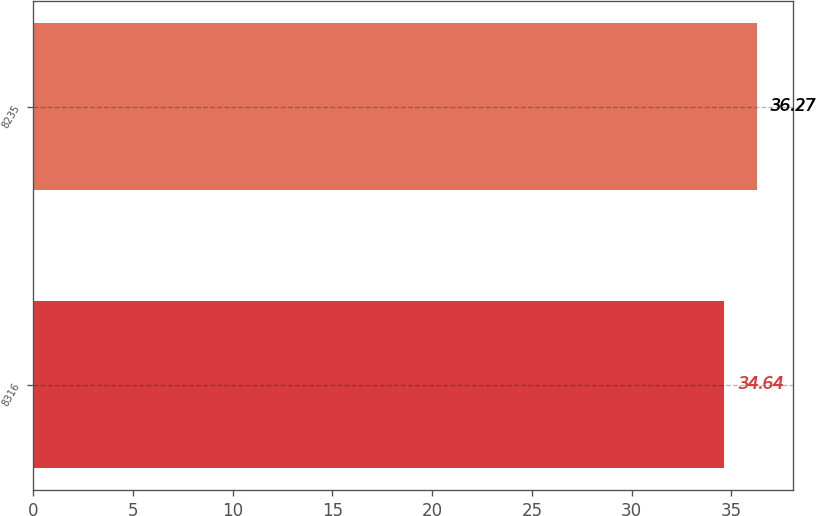Convert chart. <chart><loc_0><loc_0><loc_500><loc_500><bar_chart><fcel>8316<fcel>8235<nl><fcel>34.64<fcel>36.27<nl></chart> 